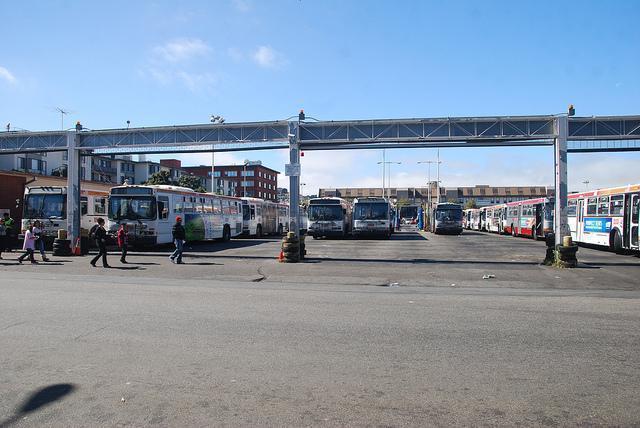How many rows of buses are visible?
Indicate the correct response and explain using: 'Answer: answer
Rationale: rationale.'
Options: Six, four, three, five. Answer: six.
Rationale: Many bus rows are visible. 